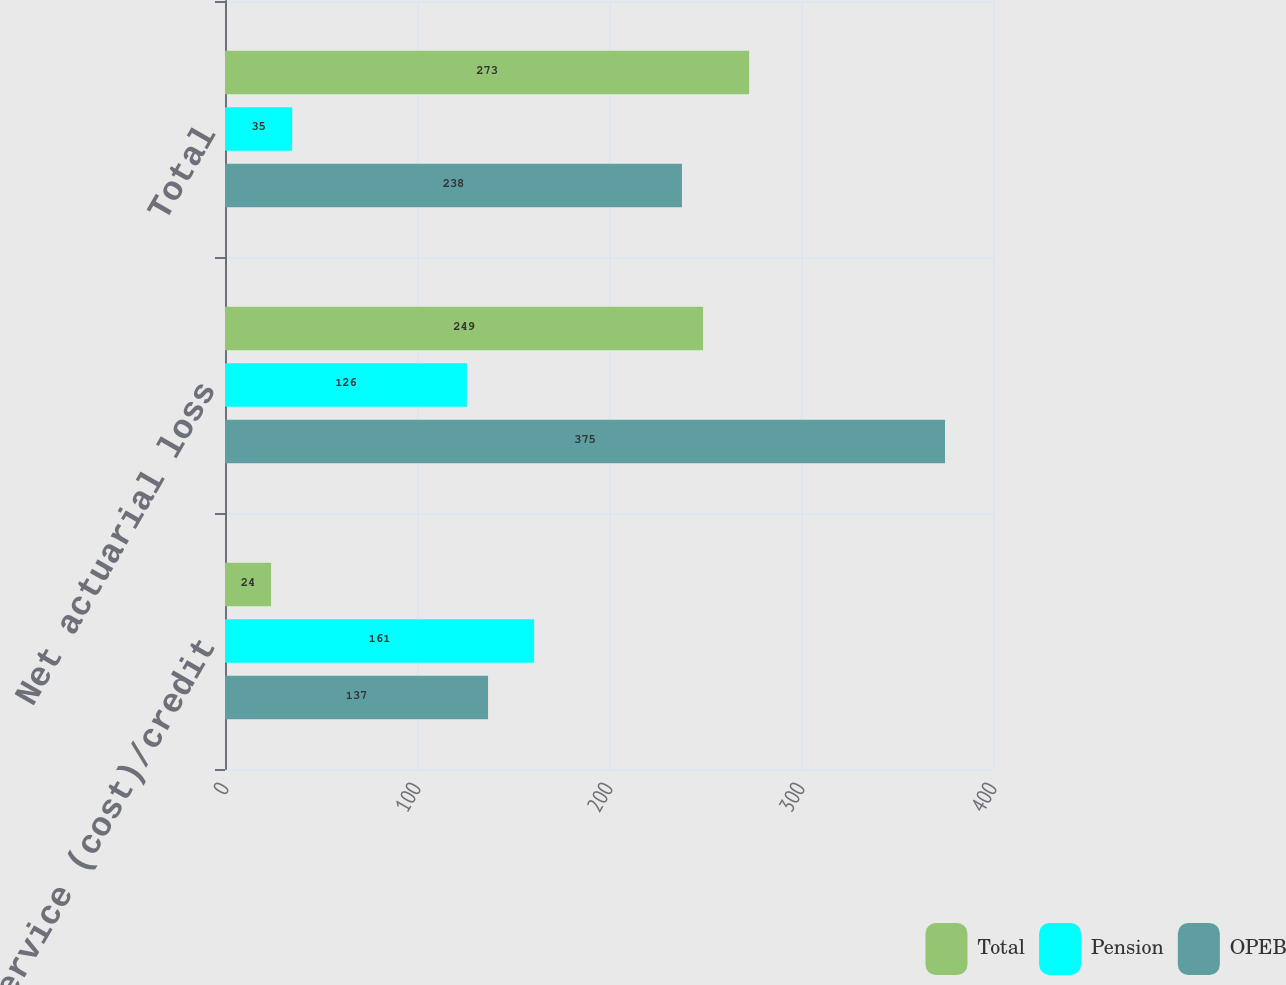<chart> <loc_0><loc_0><loc_500><loc_500><stacked_bar_chart><ecel><fcel>Prior service (cost)/credit<fcel>Net actuarial loss<fcel>Total<nl><fcel>Total<fcel>24<fcel>249<fcel>273<nl><fcel>Pension<fcel>161<fcel>126<fcel>35<nl><fcel>OPEB<fcel>137<fcel>375<fcel>238<nl></chart> 